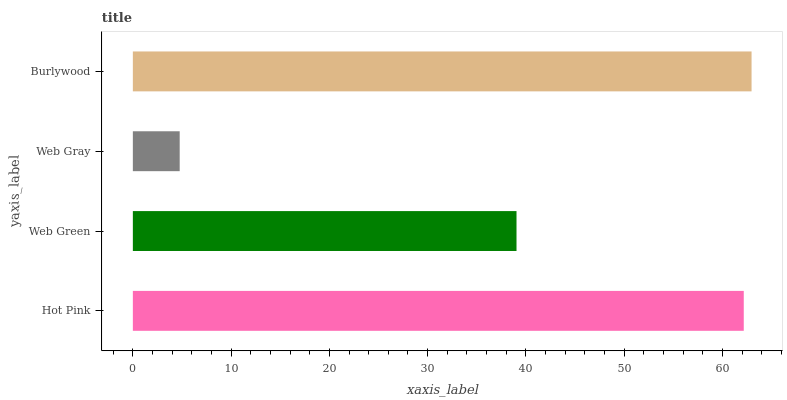Is Web Gray the minimum?
Answer yes or no. Yes. Is Burlywood the maximum?
Answer yes or no. Yes. Is Web Green the minimum?
Answer yes or no. No. Is Web Green the maximum?
Answer yes or no. No. Is Hot Pink greater than Web Green?
Answer yes or no. Yes. Is Web Green less than Hot Pink?
Answer yes or no. Yes. Is Web Green greater than Hot Pink?
Answer yes or no. No. Is Hot Pink less than Web Green?
Answer yes or no. No. Is Hot Pink the high median?
Answer yes or no. Yes. Is Web Green the low median?
Answer yes or no. Yes. Is Web Green the high median?
Answer yes or no. No. Is Burlywood the low median?
Answer yes or no. No. 